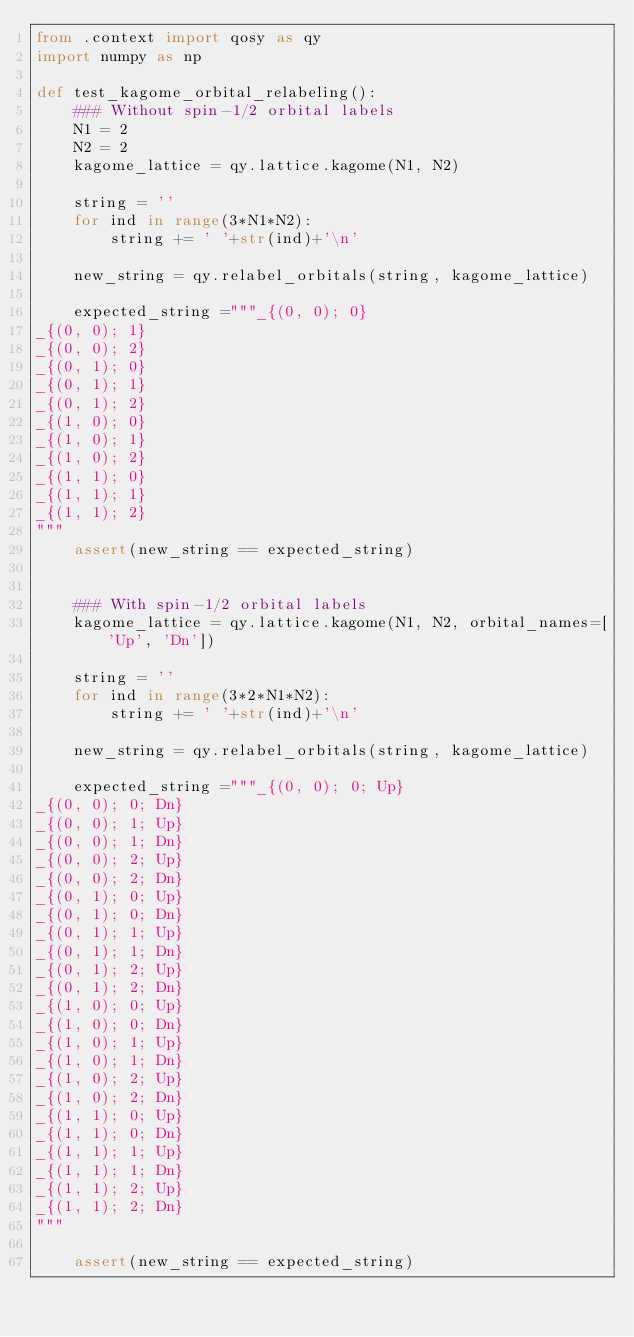Convert code to text. <code><loc_0><loc_0><loc_500><loc_500><_Python_>from .context import qosy as qy
import numpy as np

def test_kagome_orbital_relabeling():
    ### Without spin-1/2 orbital labels
    N1 = 2
    N2 = 2
    kagome_lattice = qy.lattice.kagome(N1, N2)

    string = ''
    for ind in range(3*N1*N2):
        string += ' '+str(ind)+'\n'

    new_string = qy.relabel_orbitals(string, kagome_lattice)

    expected_string ="""_{(0, 0); 0}
_{(0, 0); 1}
_{(0, 0); 2}
_{(0, 1); 0}
_{(0, 1); 1}
_{(0, 1); 2}
_{(1, 0); 0}
_{(1, 0); 1}
_{(1, 0); 2}
_{(1, 1); 0}
_{(1, 1); 1}
_{(1, 1); 2}
"""
    assert(new_string == expected_string)

    
    ### With spin-1/2 orbital labels
    kagome_lattice = qy.lattice.kagome(N1, N2, orbital_names=['Up', 'Dn'])

    string = ''
    for ind in range(3*2*N1*N2):
        string += ' '+str(ind)+'\n'

    new_string = qy.relabel_orbitals(string, kagome_lattice)

    expected_string ="""_{(0, 0); 0; Up}
_{(0, 0); 0; Dn}
_{(0, 0); 1; Up}
_{(0, 0); 1; Dn}
_{(0, 0); 2; Up}
_{(0, 0); 2; Dn}
_{(0, 1); 0; Up}
_{(0, 1); 0; Dn}
_{(0, 1); 1; Up}
_{(0, 1); 1; Dn}
_{(0, 1); 2; Up}
_{(0, 1); 2; Dn}
_{(1, 0); 0; Up}
_{(1, 0); 0; Dn}
_{(1, 0); 1; Up}
_{(1, 0); 1; Dn}
_{(1, 0); 2; Up}
_{(1, 0); 2; Dn}
_{(1, 1); 0; Up}
_{(1, 1); 0; Dn}
_{(1, 1); 1; Up}
_{(1, 1); 1; Dn}
_{(1, 1); 2; Up}
_{(1, 1); 2; Dn}
"""
    
    assert(new_string == expected_string)

    
</code> 